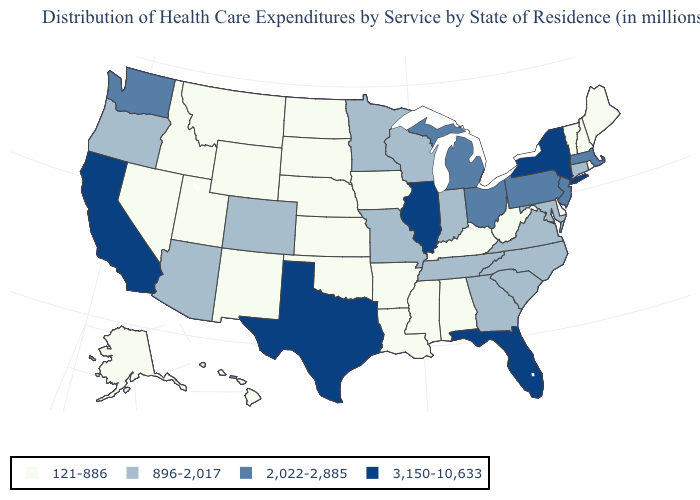Does Delaware have the same value as West Virginia?
Answer briefly. Yes. What is the value of Florida?
Write a very short answer. 3,150-10,633. Among the states that border Oklahoma , which have the lowest value?
Write a very short answer. Arkansas, Kansas, New Mexico. What is the value of Nebraska?
Give a very brief answer. 121-886. Among the states that border Rhode Island , does Massachusetts have the lowest value?
Short answer required. No. What is the value of California?
Give a very brief answer. 3,150-10,633. Does Pennsylvania have a lower value than New Hampshire?
Answer briefly. No. Which states have the lowest value in the USA?
Keep it brief. Alabama, Alaska, Arkansas, Delaware, Hawaii, Idaho, Iowa, Kansas, Kentucky, Louisiana, Maine, Mississippi, Montana, Nebraska, Nevada, New Hampshire, New Mexico, North Dakota, Oklahoma, Rhode Island, South Dakota, Utah, Vermont, West Virginia, Wyoming. What is the value of Pennsylvania?
Write a very short answer. 2,022-2,885. Name the states that have a value in the range 2,022-2,885?
Give a very brief answer. Massachusetts, Michigan, New Jersey, Ohio, Pennsylvania, Washington. Name the states that have a value in the range 2,022-2,885?
Keep it brief. Massachusetts, Michigan, New Jersey, Ohio, Pennsylvania, Washington. Among the states that border New Mexico , which have the highest value?
Write a very short answer. Texas. What is the highest value in the Northeast ?
Give a very brief answer. 3,150-10,633. Does the map have missing data?
Quick response, please. No. Is the legend a continuous bar?
Quick response, please. No. 